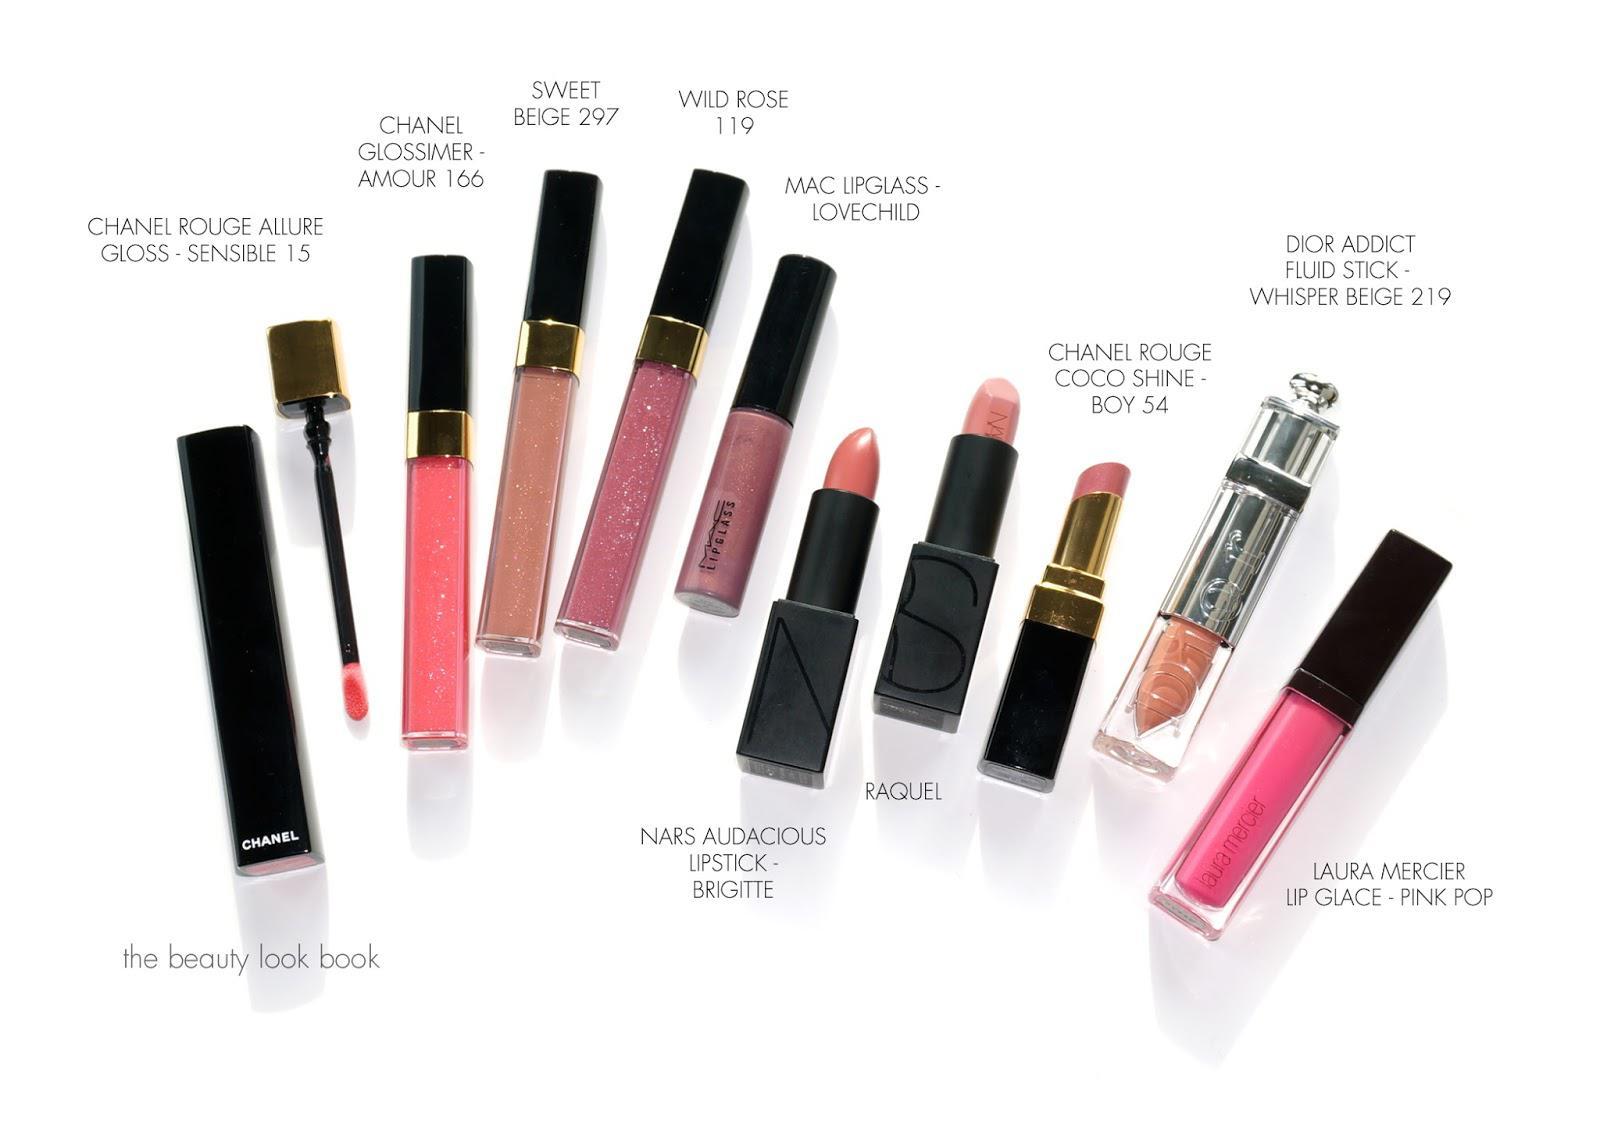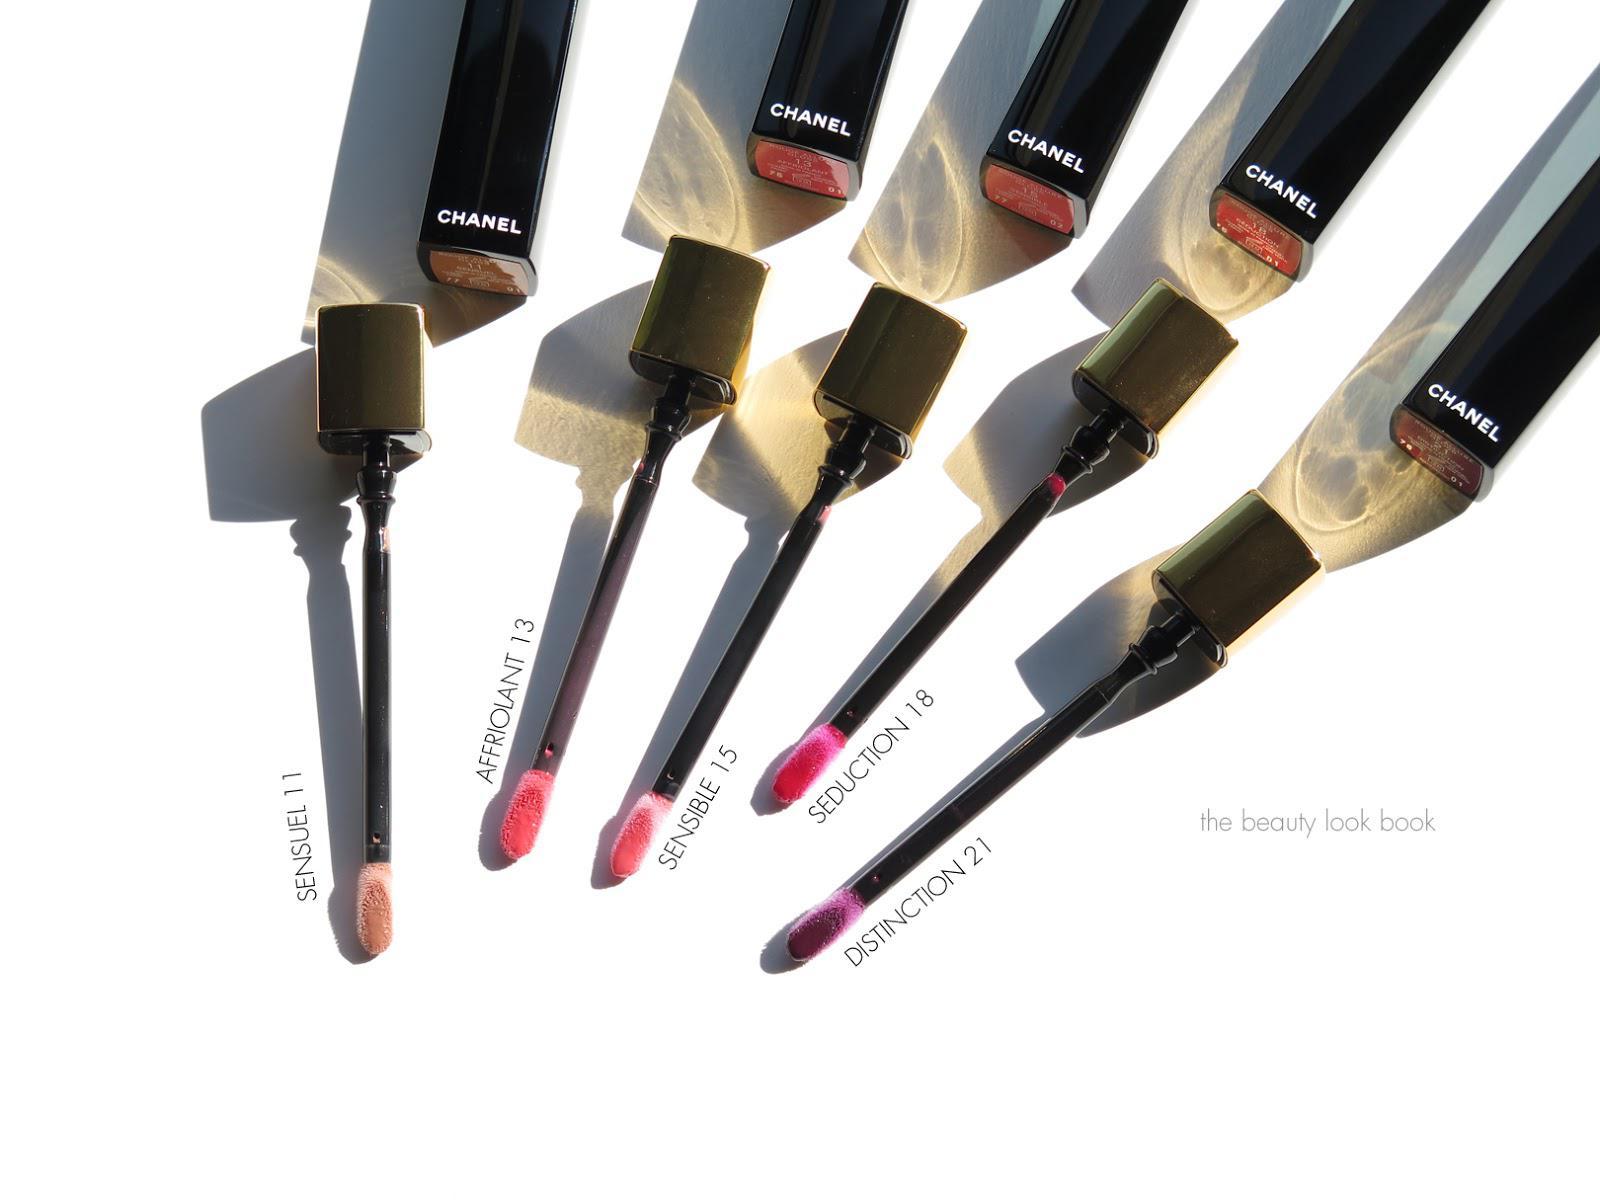The first image is the image on the left, the second image is the image on the right. For the images shown, is this caption "In one of the images, all the items are laying on their sides." true? Answer yes or no. Yes. The first image is the image on the left, the second image is the image on the right. Given the left and right images, does the statement "There are at least 9 objects standing straight up in the right image." hold true? Answer yes or no. No. 